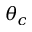Convert formula to latex. <formula><loc_0><loc_0><loc_500><loc_500>\theta _ { c }</formula> 